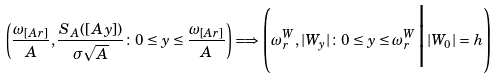Convert formula to latex. <formula><loc_0><loc_0><loc_500><loc_500>\left ( \frac { \omega _ { [ A r ] } } A , \frac { S _ { A } ( [ A y ] ) } { \sigma \sqrt { A } } \colon 0 \leq y \leq \frac { \omega _ { [ A r ] } } A \right ) \Longrightarrow \left ( \omega _ { r } ^ { W } , | W _ { y } | \colon 0 \leq y \leq \omega _ { r } ^ { W } \Big | | W _ { 0 } | = h \right )</formula> 